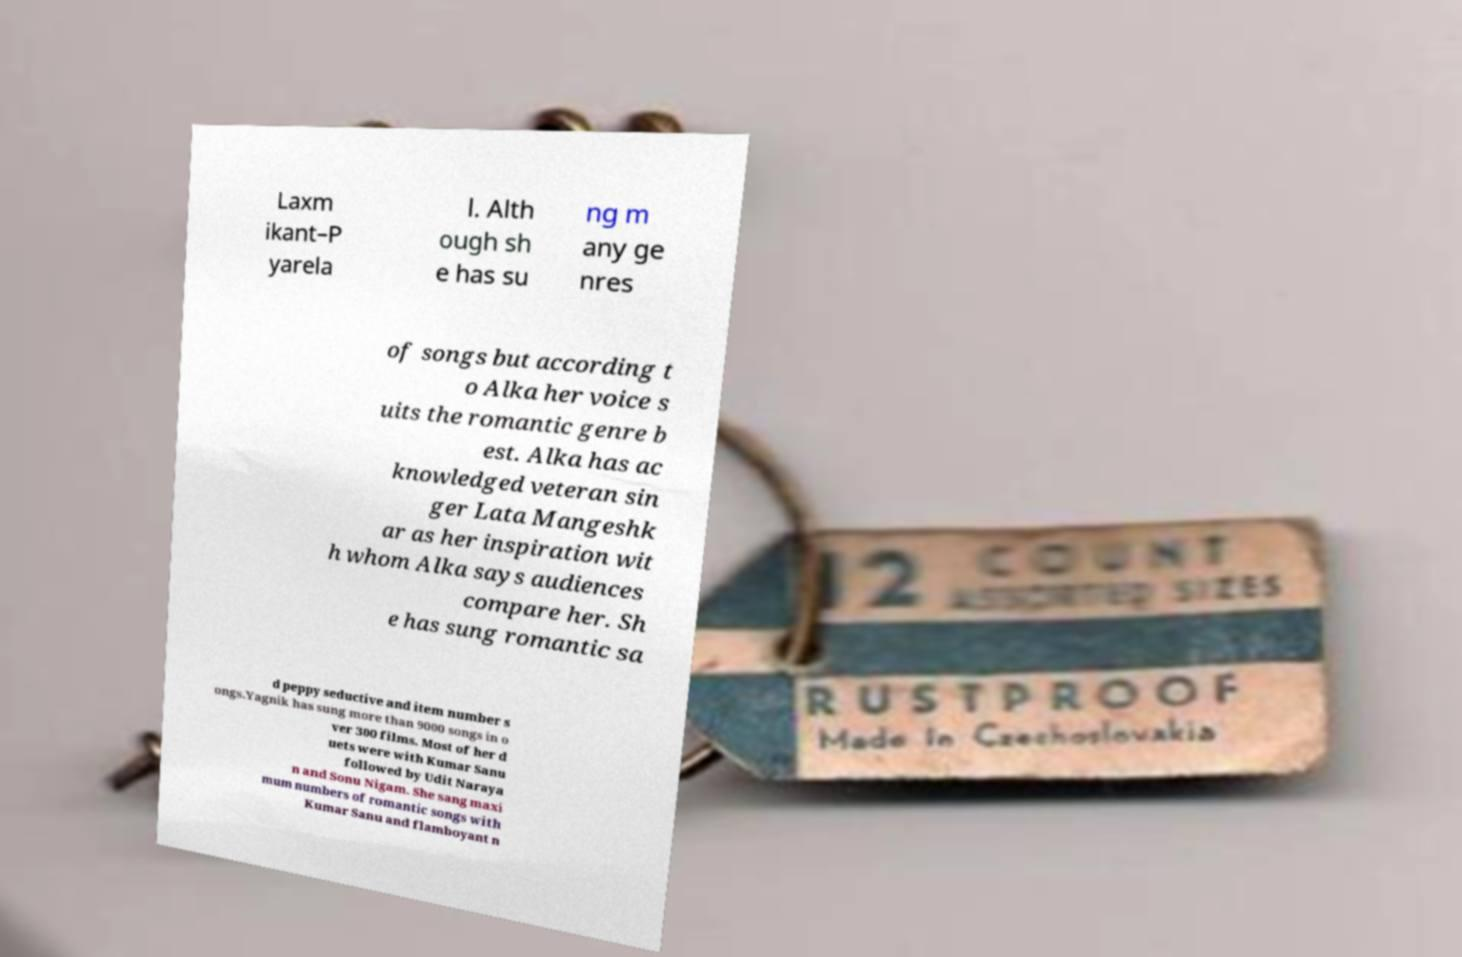What messages or text are displayed in this image? I need them in a readable, typed format. Laxm ikant–P yarela l. Alth ough sh e has su ng m any ge nres of songs but according t o Alka her voice s uits the romantic genre b est. Alka has ac knowledged veteran sin ger Lata Mangeshk ar as her inspiration wit h whom Alka says audiences compare her. Sh e has sung romantic sa d peppy seductive and item number s ongs.Yagnik has sung more than 9000 songs in o ver 300 films. Most of her d uets were with Kumar Sanu followed by Udit Naraya n and Sonu Nigam. She sang maxi mum numbers of romantic songs with Kumar Sanu and flamboyant n 